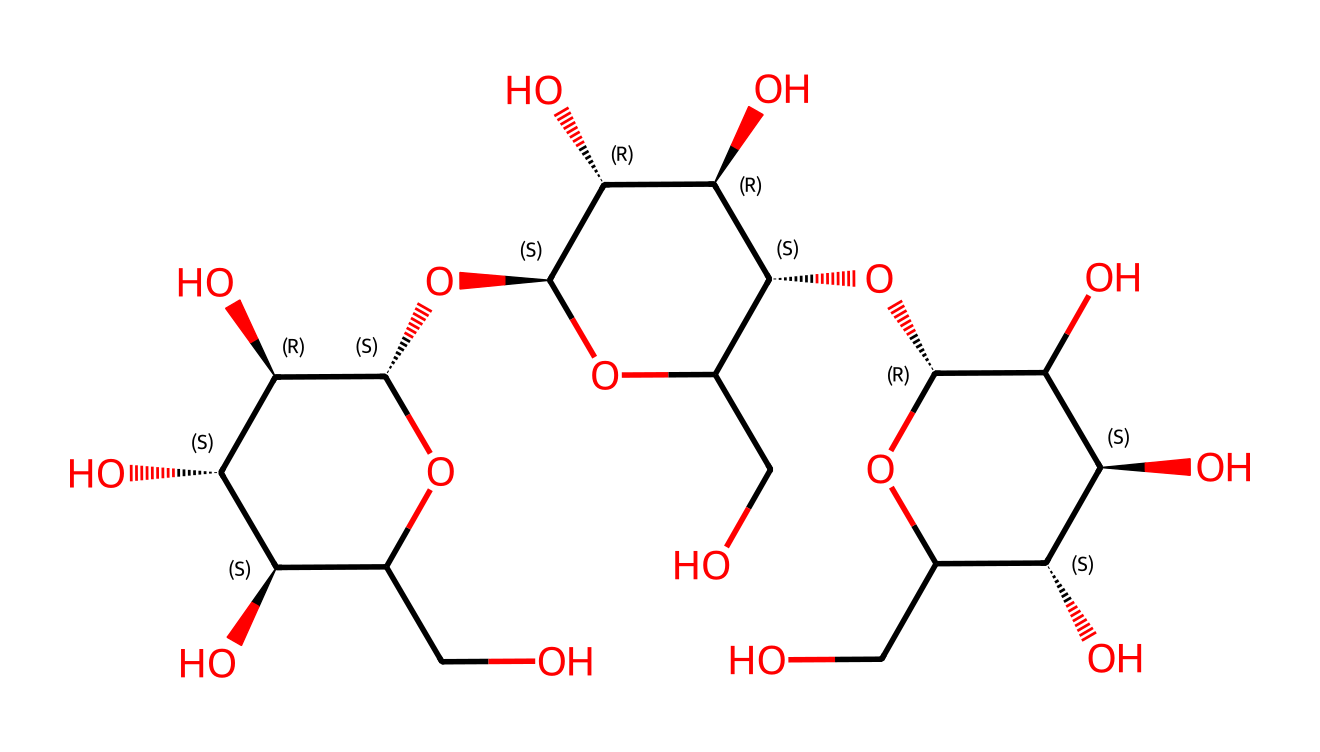What is the primary type of polymer represented in this structure? The structure corresponds to cellulose, which is a polysaccharide and a polymer made up of glucose units. Cellulose is a linear chain of β(1→4) linked glucose molecules.
Answer: cellulose How many carbon atoms are present in this molecule? By analyzing the chemical structure, we can identify the backbone consisting of glucose units. Each glucose unit contains six carbon atoms, and since there are multiple units linked together, we can count a total of 12 carbon atoms across the repeating units.
Answer: 12 What type of glycosidic linkage is predominantly found in this structure? Cellulose is characterized by beta-1,4-glycosidic linkages between the glucose units. This type of linkage contributes to the linear arrangement of cellulose, giving it structural properties.
Answer: beta-1,4 How many hydroxyl (OH) groups are present in the entire structure? Each glucose unit has multiple hydroxyl groups (-OH) attached, and by examining the structure, there are a total of 10 hydroxyl groups linked to the carbon backbone in this polymer.
Answer: 10 Does this molecule represent a soluble or insoluble fiber? Cellulose is known for its insolubility in water due to its tightly-packed structures and extensive hydrogen bonding between chains, making it a key component of dietary fiber.
Answer: insoluble Which feature of cellulose contributes to its strength? The extensive hydrogen bonding between hydroxyl groups of adjacent cellulose chains creates a rigid structure that provides strength and resistance to degradation. This hydrogen bonding is a critical property for structural integrity.
Answer: hydrogen bonding How many rings are present in the monosaccharide units of this structure? In this cellulose structure, each glucose unit has a cyclic form, typically illustrated as a six-membered ring (pyranose). As there are multiple glucose units, each contributes one ring, resulting in four rings total.
Answer: 4 